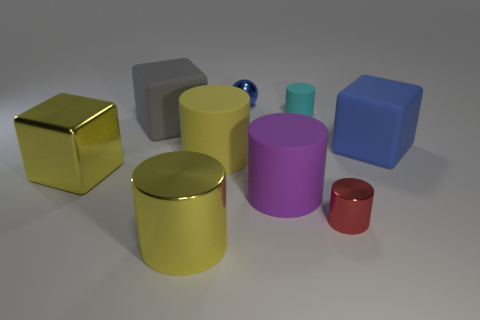There is another rubber object that is the same shape as the large gray matte object; what color is it?
Keep it short and to the point. Blue. There is a cube that is the same color as the big shiny cylinder; what is its material?
Your response must be concise. Metal. What color is the small metal object in front of the cyan cylinder?
Keep it short and to the point. Red. Is the big metal cylinder the same color as the shiny cube?
Ensure brevity in your answer.  Yes. There is a blue thing on the left side of the large cube that is to the right of the tiny red thing; what number of cyan matte cylinders are to the left of it?
Provide a succinct answer. 0. How big is the red thing?
Give a very brief answer. Small. There is a yellow cube that is the same size as the purple rubber thing; what is its material?
Your response must be concise. Metal. There is a large gray thing; how many blue blocks are in front of it?
Give a very brief answer. 1. Are the blue object that is on the right side of the small blue ball and the small cylinder behind the big gray block made of the same material?
Ensure brevity in your answer.  Yes. There is a big rubber object that is in front of the large rubber cylinder that is to the left of the small metallic thing that is behind the red object; what shape is it?
Your answer should be compact. Cylinder. 